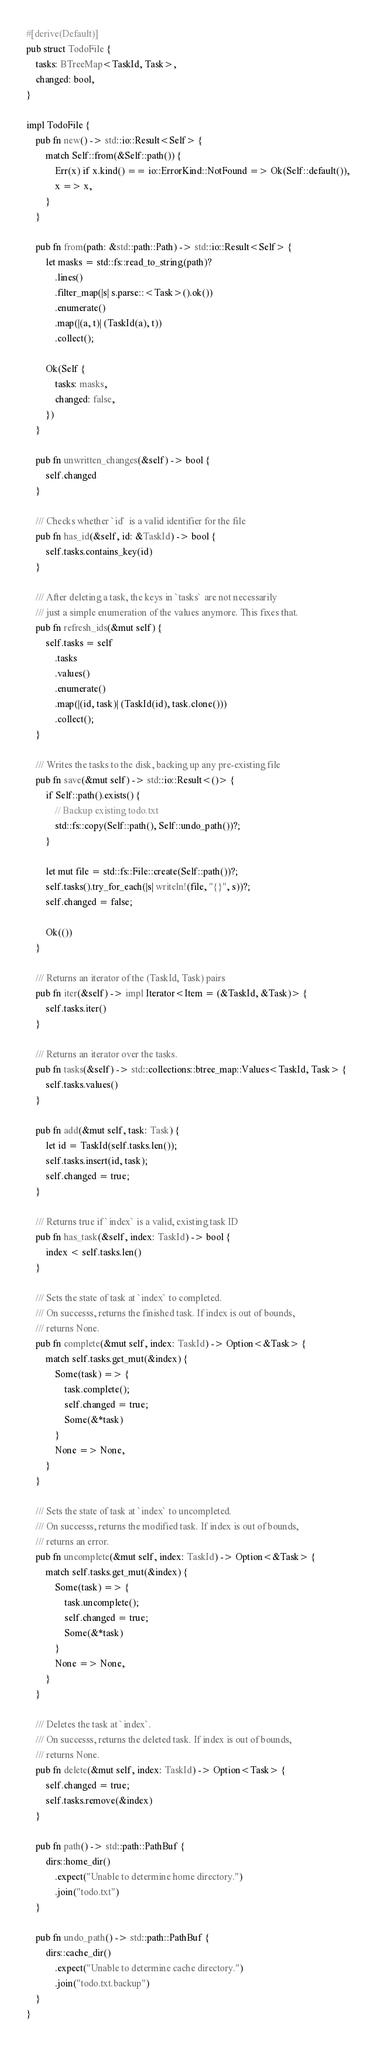Convert code to text. <code><loc_0><loc_0><loc_500><loc_500><_Rust_>
#[derive(Default)]
pub struct TodoFile {
    tasks: BTreeMap<TaskId, Task>,
    changed: bool,
}

impl TodoFile {
    pub fn new() -> std::io::Result<Self> {
        match Self::from(&Self::path()) {
            Err(x) if x.kind() == io::ErrorKind::NotFound => Ok(Self::default()),
            x => x,
        }
    }

    pub fn from(path: &std::path::Path) -> std::io::Result<Self> {
        let masks = std::fs::read_to_string(path)?
            .lines()
            .filter_map(|s| s.parse::<Task>().ok())
            .enumerate()
            .map(|(a, t)| (TaskId(a), t))
            .collect();

        Ok(Self {
            tasks: masks,
            changed: false,
        })
    }

    pub fn unwritten_changes(&self) -> bool {
        self.changed
    }

    /// Checks whether `id` is a valid identifier for the file
    pub fn has_id(&self, id: &TaskId) -> bool {
        self.tasks.contains_key(id)
    }

    /// After deleting a task, the keys in `tasks` are not necessarily
    /// just a simple enumeration of the values anymore. This fixes that.
    pub fn refresh_ids(&mut self) {
        self.tasks = self
            .tasks
            .values()
            .enumerate()
            .map(|(id, task)| (TaskId(id), task.clone()))
            .collect();
    }

    /// Writes the tasks to the disk, backing up any pre-existing file
    pub fn save(&mut self) -> std::io::Result<()> {
        if Self::path().exists() {
            // Backup existing todo.txt
            std::fs::copy(Self::path(), Self::undo_path())?;
        }

        let mut file = std::fs::File::create(Self::path())?;
        self.tasks().try_for_each(|s| writeln!(file, "{}", s))?;
        self.changed = false;

        Ok(())
    }

    /// Returns an iterator of the (TaskId, Task) pairs
    pub fn iter(&self) -> impl Iterator<Item = (&TaskId, &Task)> {
        self.tasks.iter()
    }

    /// Returns an iterator over the tasks.
    pub fn tasks(&self) -> std::collections::btree_map::Values<TaskId, Task> {
        self.tasks.values()
    }

    pub fn add(&mut self, task: Task) {
        let id = TaskId(self.tasks.len());
        self.tasks.insert(id, task);
        self.changed = true;
    }

    /// Returns true if `index` is a valid, existing task ID
    pub fn has_task(&self, index: TaskId) -> bool {
        index < self.tasks.len()
    }

    /// Sets the state of task at `index` to completed.
    /// On successs, returns the finished task. If index is out of bounds,
    /// returns None.
    pub fn complete(&mut self, index: TaskId) -> Option<&Task> {
        match self.tasks.get_mut(&index) {
            Some(task) => {
                task.complete();
                self.changed = true;
                Some(&*task)
            }
            None => None,
        }
    }

    /// Sets the state of task at `index` to uncompleted.
    /// On successs, returns the modified task. If index is out of bounds,
    /// returns an error.
    pub fn uncomplete(&mut self, index: TaskId) -> Option<&Task> {
        match self.tasks.get_mut(&index) {
            Some(task) => {
                task.uncomplete();
                self.changed = true;
                Some(&*task)
            }
            None => None,
        }
    }

    /// Deletes the task at `index`.
    /// On successs, returns the deleted task. If index is out of bounds,
    /// returns None.
    pub fn delete(&mut self, index: TaskId) -> Option<Task> {
        self.changed = true;
        self.tasks.remove(&index)
    }

    pub fn path() -> std::path::PathBuf {
        dirs::home_dir()
            .expect("Unable to determine home directory.")
            .join("todo.txt")
    }

    pub fn undo_path() -> std::path::PathBuf {
        dirs::cache_dir()
            .expect("Unable to determine cache directory.")
            .join("todo.txt.backup")
    }
}
</code> 